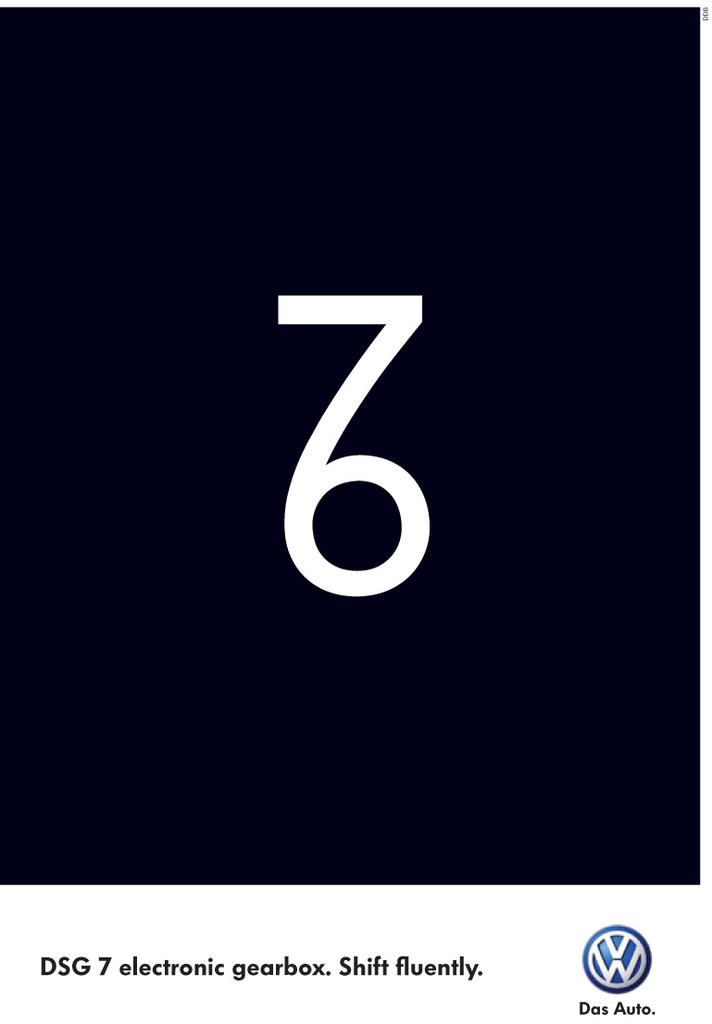<image>
Render a clear and concise summary of the photo. Black background with the numbers 7 and 6 on it. 